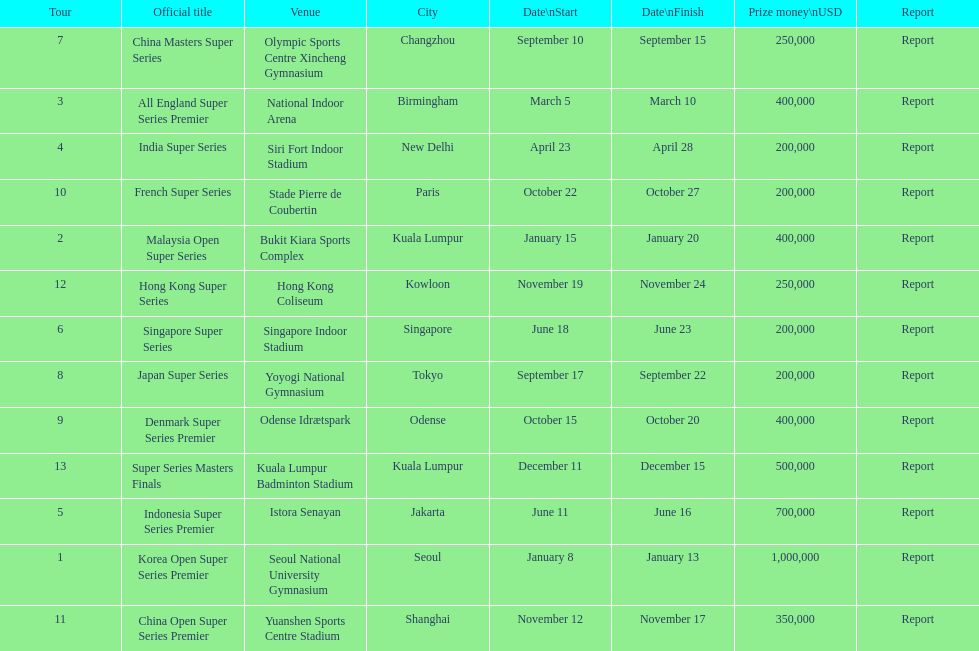How many tours took place during january? 2. 